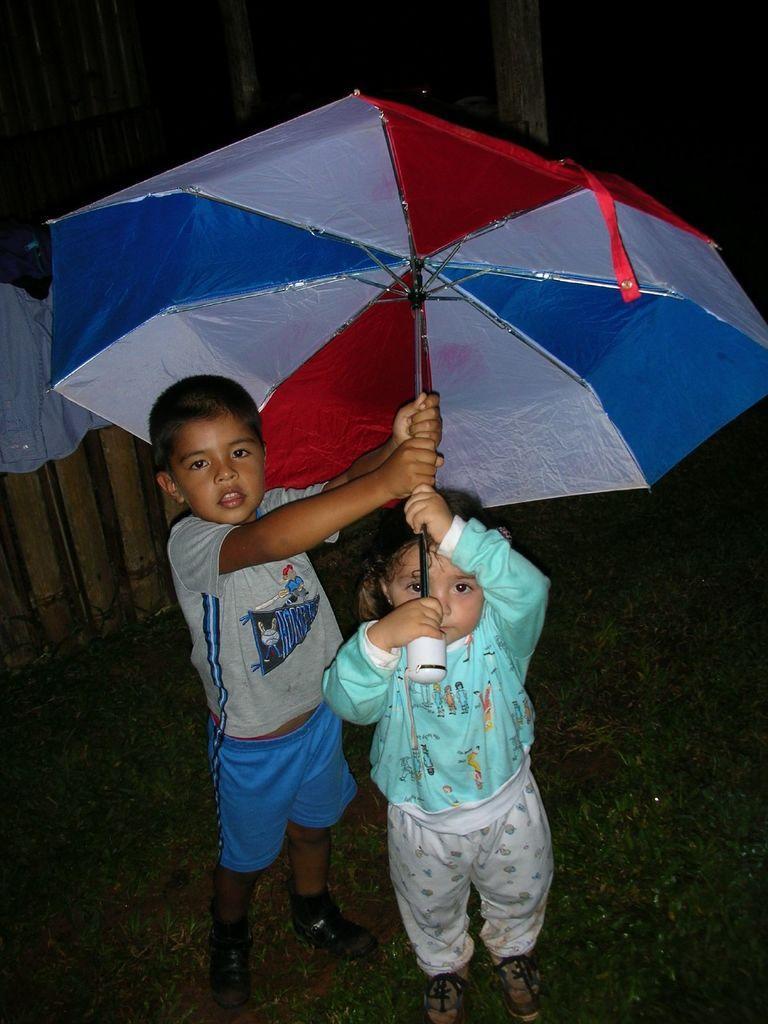Can you describe this image briefly? Here we can see a boy and a girl are standing on the ground by holding an umbrella with their hands on them. In the background we can see a cloth on an object,wooden pole and some other objects. 